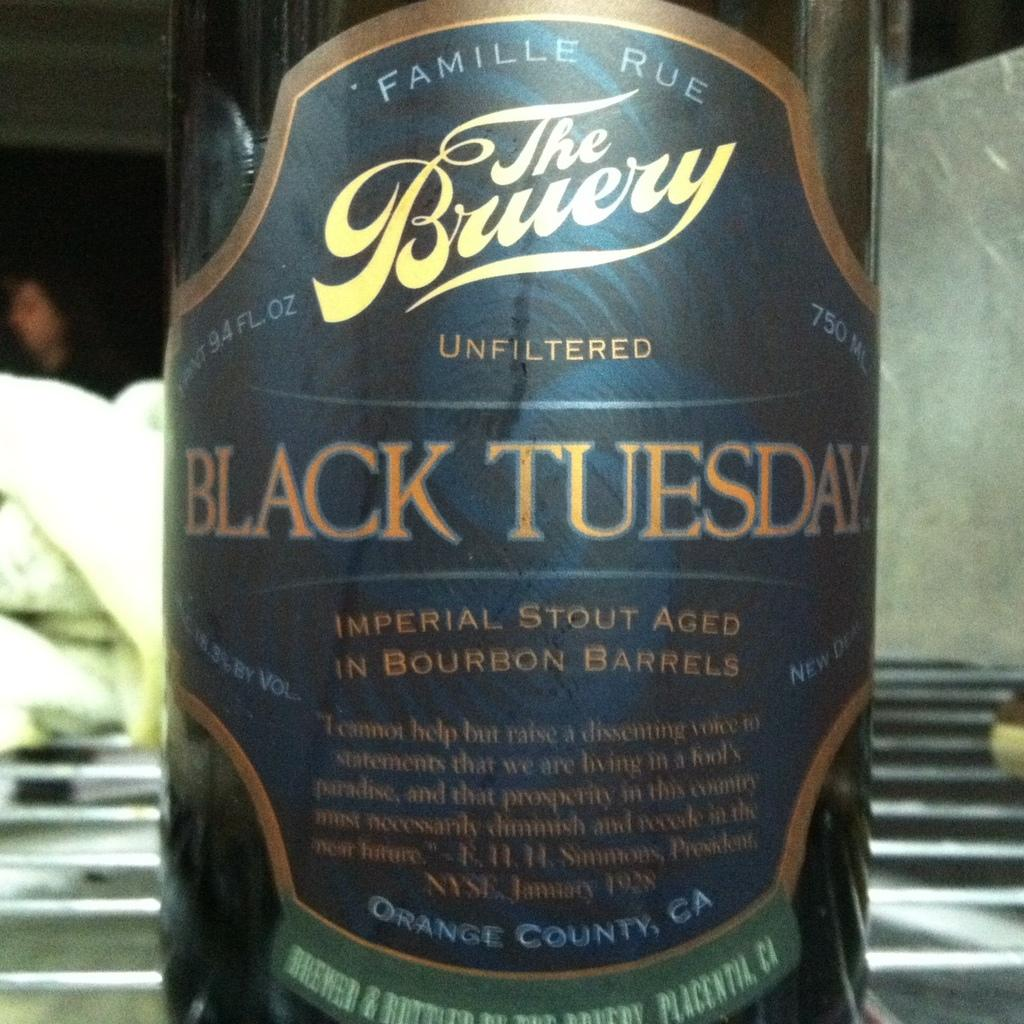<image>
Render a clear and concise summary of the photo. The label for a bottle of Black Tuesday imperial stout that has been aged in bourban barrels. 